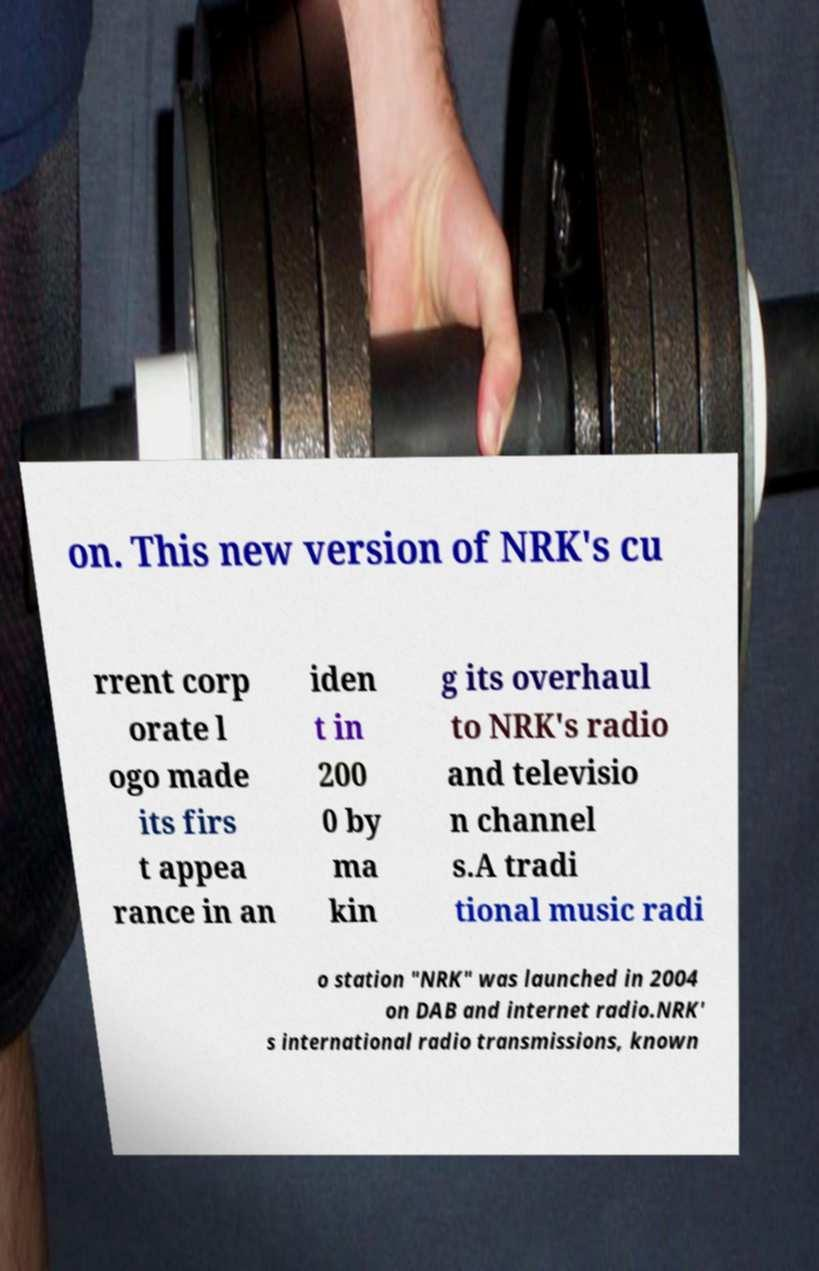I need the written content from this picture converted into text. Can you do that? on. This new version of NRK's cu rrent corp orate l ogo made its firs t appea rance in an iden t in 200 0 by ma kin g its overhaul to NRK's radio and televisio n channel s.A tradi tional music radi o station "NRK" was launched in 2004 on DAB and internet radio.NRK' s international radio transmissions, known 